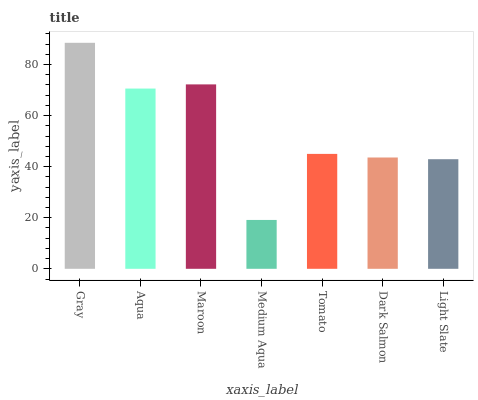Is Medium Aqua the minimum?
Answer yes or no. Yes. Is Gray the maximum?
Answer yes or no. Yes. Is Aqua the minimum?
Answer yes or no. No. Is Aqua the maximum?
Answer yes or no. No. Is Gray greater than Aqua?
Answer yes or no. Yes. Is Aqua less than Gray?
Answer yes or no. Yes. Is Aqua greater than Gray?
Answer yes or no. No. Is Gray less than Aqua?
Answer yes or no. No. Is Tomato the high median?
Answer yes or no. Yes. Is Tomato the low median?
Answer yes or no. Yes. Is Gray the high median?
Answer yes or no. No. Is Aqua the low median?
Answer yes or no. No. 